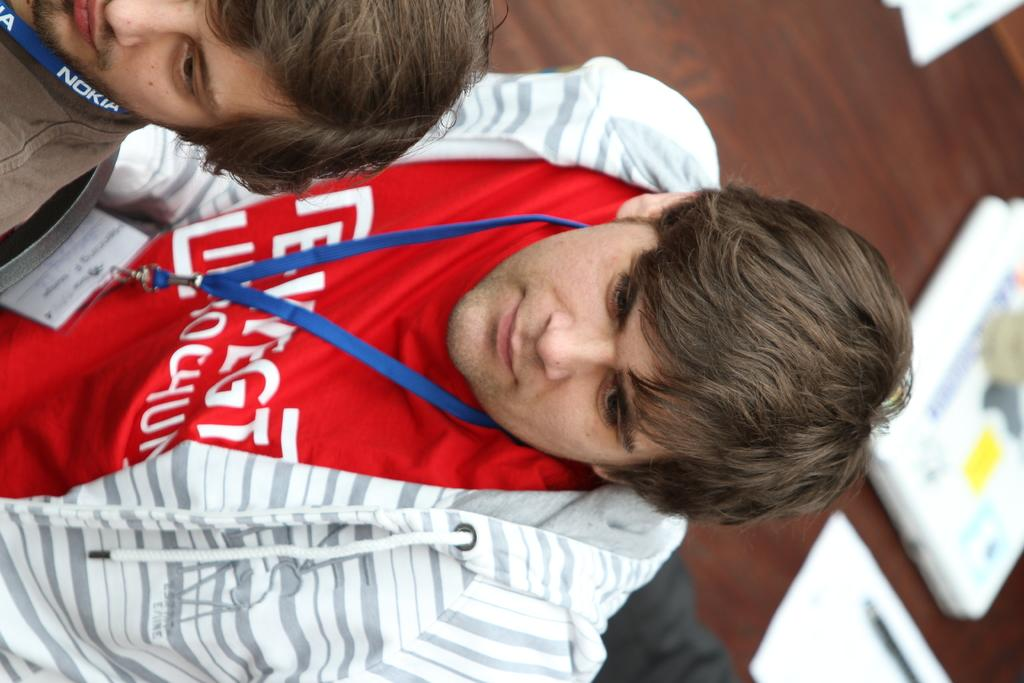Provide a one-sentence caption for the provided image. two men with lanyards around their necks with one reading NOKIA. 